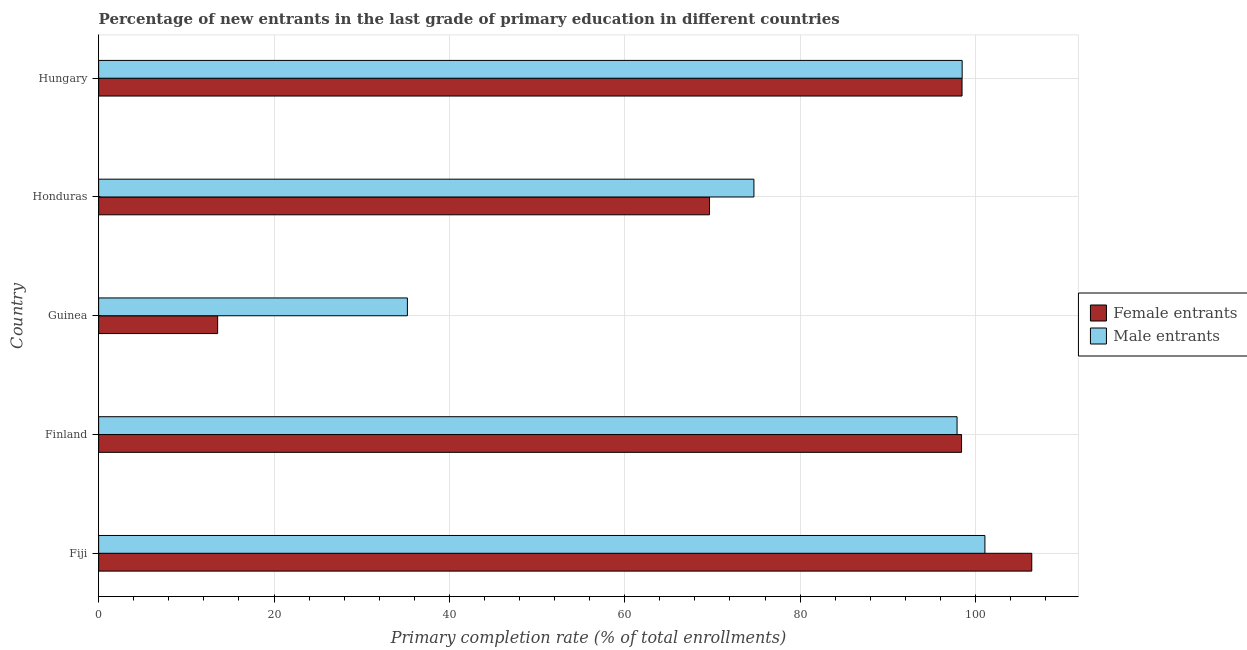How many different coloured bars are there?
Your response must be concise. 2. Are the number of bars per tick equal to the number of legend labels?
Keep it short and to the point. Yes. Are the number of bars on each tick of the Y-axis equal?
Ensure brevity in your answer.  Yes. What is the label of the 2nd group of bars from the top?
Your answer should be very brief. Honduras. What is the primary completion rate of male entrants in Finland?
Make the answer very short. 97.9. Across all countries, what is the maximum primary completion rate of female entrants?
Your response must be concise. 106.43. Across all countries, what is the minimum primary completion rate of male entrants?
Provide a short and direct response. 35.21. In which country was the primary completion rate of female entrants maximum?
Keep it short and to the point. Fiji. In which country was the primary completion rate of male entrants minimum?
Ensure brevity in your answer.  Guinea. What is the total primary completion rate of male entrants in the graph?
Your response must be concise. 407.42. What is the difference between the primary completion rate of female entrants in Fiji and that in Finland?
Offer a very short reply. 8.01. What is the difference between the primary completion rate of male entrants in Honduras and the primary completion rate of female entrants in Guinea?
Keep it short and to the point. 61.16. What is the average primary completion rate of female entrants per country?
Make the answer very short. 77.31. What is the difference between the primary completion rate of female entrants and primary completion rate of male entrants in Fiji?
Offer a very short reply. 5.34. What is the ratio of the primary completion rate of female entrants in Honduras to that in Hungary?
Provide a succinct answer. 0.71. Is the primary completion rate of female entrants in Fiji less than that in Guinea?
Provide a short and direct response. No. Is the difference between the primary completion rate of female entrants in Finland and Guinea greater than the difference between the primary completion rate of male entrants in Finland and Guinea?
Give a very brief answer. Yes. What is the difference between the highest and the second highest primary completion rate of female entrants?
Keep it short and to the point. 7.95. What is the difference between the highest and the lowest primary completion rate of female entrants?
Provide a short and direct response. 92.85. Is the sum of the primary completion rate of male entrants in Finland and Hungary greater than the maximum primary completion rate of female entrants across all countries?
Offer a very short reply. Yes. What does the 2nd bar from the top in Hungary represents?
Ensure brevity in your answer.  Female entrants. What does the 2nd bar from the bottom in Fiji represents?
Your answer should be very brief. Male entrants. Does the graph contain any zero values?
Ensure brevity in your answer.  No. How many legend labels are there?
Ensure brevity in your answer.  2. How are the legend labels stacked?
Make the answer very short. Vertical. What is the title of the graph?
Provide a succinct answer. Percentage of new entrants in the last grade of primary education in different countries. What is the label or title of the X-axis?
Your answer should be very brief. Primary completion rate (% of total enrollments). What is the Primary completion rate (% of total enrollments) of Female entrants in Fiji?
Give a very brief answer. 106.43. What is the Primary completion rate (% of total enrollments) in Male entrants in Fiji?
Provide a short and direct response. 101.08. What is the Primary completion rate (% of total enrollments) of Female entrants in Finland?
Offer a very short reply. 98.42. What is the Primary completion rate (% of total enrollments) in Male entrants in Finland?
Keep it short and to the point. 97.9. What is the Primary completion rate (% of total enrollments) of Female entrants in Guinea?
Your response must be concise. 13.57. What is the Primary completion rate (% of total enrollments) in Male entrants in Guinea?
Your answer should be compact. 35.21. What is the Primary completion rate (% of total enrollments) of Female entrants in Honduras?
Keep it short and to the point. 69.67. What is the Primary completion rate (% of total enrollments) of Male entrants in Honduras?
Offer a very short reply. 74.74. What is the Primary completion rate (% of total enrollments) of Female entrants in Hungary?
Your answer should be very brief. 98.47. What is the Primary completion rate (% of total enrollments) of Male entrants in Hungary?
Your answer should be compact. 98.49. Across all countries, what is the maximum Primary completion rate (% of total enrollments) in Female entrants?
Offer a terse response. 106.43. Across all countries, what is the maximum Primary completion rate (% of total enrollments) in Male entrants?
Your answer should be very brief. 101.08. Across all countries, what is the minimum Primary completion rate (% of total enrollments) of Female entrants?
Provide a short and direct response. 13.57. Across all countries, what is the minimum Primary completion rate (% of total enrollments) in Male entrants?
Offer a very short reply. 35.21. What is the total Primary completion rate (% of total enrollments) of Female entrants in the graph?
Offer a terse response. 386.56. What is the total Primary completion rate (% of total enrollments) of Male entrants in the graph?
Give a very brief answer. 407.42. What is the difference between the Primary completion rate (% of total enrollments) of Female entrants in Fiji and that in Finland?
Ensure brevity in your answer.  8.01. What is the difference between the Primary completion rate (% of total enrollments) in Male entrants in Fiji and that in Finland?
Ensure brevity in your answer.  3.18. What is the difference between the Primary completion rate (% of total enrollments) of Female entrants in Fiji and that in Guinea?
Ensure brevity in your answer.  92.85. What is the difference between the Primary completion rate (% of total enrollments) in Male entrants in Fiji and that in Guinea?
Your answer should be very brief. 65.87. What is the difference between the Primary completion rate (% of total enrollments) in Female entrants in Fiji and that in Honduras?
Your answer should be very brief. 36.75. What is the difference between the Primary completion rate (% of total enrollments) of Male entrants in Fiji and that in Honduras?
Provide a succinct answer. 26.34. What is the difference between the Primary completion rate (% of total enrollments) of Female entrants in Fiji and that in Hungary?
Your answer should be compact. 7.95. What is the difference between the Primary completion rate (% of total enrollments) of Male entrants in Fiji and that in Hungary?
Your answer should be very brief. 2.6. What is the difference between the Primary completion rate (% of total enrollments) of Female entrants in Finland and that in Guinea?
Make the answer very short. 84.84. What is the difference between the Primary completion rate (% of total enrollments) in Male entrants in Finland and that in Guinea?
Make the answer very short. 62.69. What is the difference between the Primary completion rate (% of total enrollments) in Female entrants in Finland and that in Honduras?
Your response must be concise. 28.74. What is the difference between the Primary completion rate (% of total enrollments) in Male entrants in Finland and that in Honduras?
Keep it short and to the point. 23.17. What is the difference between the Primary completion rate (% of total enrollments) in Female entrants in Finland and that in Hungary?
Ensure brevity in your answer.  -0.06. What is the difference between the Primary completion rate (% of total enrollments) in Male entrants in Finland and that in Hungary?
Make the answer very short. -0.58. What is the difference between the Primary completion rate (% of total enrollments) in Female entrants in Guinea and that in Honduras?
Make the answer very short. -56.1. What is the difference between the Primary completion rate (% of total enrollments) of Male entrants in Guinea and that in Honduras?
Offer a terse response. -39.52. What is the difference between the Primary completion rate (% of total enrollments) of Female entrants in Guinea and that in Hungary?
Ensure brevity in your answer.  -84.9. What is the difference between the Primary completion rate (% of total enrollments) of Male entrants in Guinea and that in Hungary?
Keep it short and to the point. -63.27. What is the difference between the Primary completion rate (% of total enrollments) of Female entrants in Honduras and that in Hungary?
Give a very brief answer. -28.8. What is the difference between the Primary completion rate (% of total enrollments) of Male entrants in Honduras and that in Hungary?
Offer a very short reply. -23.75. What is the difference between the Primary completion rate (% of total enrollments) of Female entrants in Fiji and the Primary completion rate (% of total enrollments) of Male entrants in Finland?
Provide a short and direct response. 8.52. What is the difference between the Primary completion rate (% of total enrollments) of Female entrants in Fiji and the Primary completion rate (% of total enrollments) of Male entrants in Guinea?
Your response must be concise. 71.21. What is the difference between the Primary completion rate (% of total enrollments) in Female entrants in Fiji and the Primary completion rate (% of total enrollments) in Male entrants in Honduras?
Your answer should be compact. 31.69. What is the difference between the Primary completion rate (% of total enrollments) of Female entrants in Fiji and the Primary completion rate (% of total enrollments) of Male entrants in Hungary?
Offer a very short reply. 7.94. What is the difference between the Primary completion rate (% of total enrollments) of Female entrants in Finland and the Primary completion rate (% of total enrollments) of Male entrants in Guinea?
Your answer should be compact. 63.2. What is the difference between the Primary completion rate (% of total enrollments) in Female entrants in Finland and the Primary completion rate (% of total enrollments) in Male entrants in Honduras?
Keep it short and to the point. 23.68. What is the difference between the Primary completion rate (% of total enrollments) of Female entrants in Finland and the Primary completion rate (% of total enrollments) of Male entrants in Hungary?
Offer a terse response. -0.07. What is the difference between the Primary completion rate (% of total enrollments) in Female entrants in Guinea and the Primary completion rate (% of total enrollments) in Male entrants in Honduras?
Ensure brevity in your answer.  -61.16. What is the difference between the Primary completion rate (% of total enrollments) of Female entrants in Guinea and the Primary completion rate (% of total enrollments) of Male entrants in Hungary?
Give a very brief answer. -84.91. What is the difference between the Primary completion rate (% of total enrollments) of Female entrants in Honduras and the Primary completion rate (% of total enrollments) of Male entrants in Hungary?
Offer a very short reply. -28.81. What is the average Primary completion rate (% of total enrollments) of Female entrants per country?
Give a very brief answer. 77.31. What is the average Primary completion rate (% of total enrollments) of Male entrants per country?
Your answer should be compact. 81.48. What is the difference between the Primary completion rate (% of total enrollments) of Female entrants and Primary completion rate (% of total enrollments) of Male entrants in Fiji?
Provide a succinct answer. 5.34. What is the difference between the Primary completion rate (% of total enrollments) of Female entrants and Primary completion rate (% of total enrollments) of Male entrants in Finland?
Provide a succinct answer. 0.51. What is the difference between the Primary completion rate (% of total enrollments) of Female entrants and Primary completion rate (% of total enrollments) of Male entrants in Guinea?
Your answer should be compact. -21.64. What is the difference between the Primary completion rate (% of total enrollments) in Female entrants and Primary completion rate (% of total enrollments) in Male entrants in Honduras?
Ensure brevity in your answer.  -5.07. What is the difference between the Primary completion rate (% of total enrollments) of Female entrants and Primary completion rate (% of total enrollments) of Male entrants in Hungary?
Keep it short and to the point. -0.01. What is the ratio of the Primary completion rate (% of total enrollments) of Female entrants in Fiji to that in Finland?
Provide a short and direct response. 1.08. What is the ratio of the Primary completion rate (% of total enrollments) in Male entrants in Fiji to that in Finland?
Keep it short and to the point. 1.03. What is the ratio of the Primary completion rate (% of total enrollments) in Female entrants in Fiji to that in Guinea?
Offer a terse response. 7.84. What is the ratio of the Primary completion rate (% of total enrollments) in Male entrants in Fiji to that in Guinea?
Provide a succinct answer. 2.87. What is the ratio of the Primary completion rate (% of total enrollments) in Female entrants in Fiji to that in Honduras?
Give a very brief answer. 1.53. What is the ratio of the Primary completion rate (% of total enrollments) of Male entrants in Fiji to that in Honduras?
Provide a succinct answer. 1.35. What is the ratio of the Primary completion rate (% of total enrollments) of Female entrants in Fiji to that in Hungary?
Offer a terse response. 1.08. What is the ratio of the Primary completion rate (% of total enrollments) in Male entrants in Fiji to that in Hungary?
Your response must be concise. 1.03. What is the ratio of the Primary completion rate (% of total enrollments) of Female entrants in Finland to that in Guinea?
Your answer should be compact. 7.25. What is the ratio of the Primary completion rate (% of total enrollments) of Male entrants in Finland to that in Guinea?
Your response must be concise. 2.78. What is the ratio of the Primary completion rate (% of total enrollments) of Female entrants in Finland to that in Honduras?
Your response must be concise. 1.41. What is the ratio of the Primary completion rate (% of total enrollments) of Male entrants in Finland to that in Honduras?
Your answer should be very brief. 1.31. What is the ratio of the Primary completion rate (% of total enrollments) in Female entrants in Guinea to that in Honduras?
Provide a succinct answer. 0.19. What is the ratio of the Primary completion rate (% of total enrollments) of Male entrants in Guinea to that in Honduras?
Keep it short and to the point. 0.47. What is the ratio of the Primary completion rate (% of total enrollments) of Female entrants in Guinea to that in Hungary?
Ensure brevity in your answer.  0.14. What is the ratio of the Primary completion rate (% of total enrollments) of Male entrants in Guinea to that in Hungary?
Your response must be concise. 0.36. What is the ratio of the Primary completion rate (% of total enrollments) in Female entrants in Honduras to that in Hungary?
Make the answer very short. 0.71. What is the ratio of the Primary completion rate (% of total enrollments) of Male entrants in Honduras to that in Hungary?
Offer a very short reply. 0.76. What is the difference between the highest and the second highest Primary completion rate (% of total enrollments) of Female entrants?
Offer a very short reply. 7.95. What is the difference between the highest and the second highest Primary completion rate (% of total enrollments) of Male entrants?
Provide a short and direct response. 2.6. What is the difference between the highest and the lowest Primary completion rate (% of total enrollments) of Female entrants?
Your answer should be compact. 92.85. What is the difference between the highest and the lowest Primary completion rate (% of total enrollments) of Male entrants?
Your response must be concise. 65.87. 